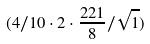<formula> <loc_0><loc_0><loc_500><loc_500>( 4 / 1 0 \cdot 2 \cdot \frac { 2 2 1 } { 8 } / \sqrt { 1 } )</formula> 